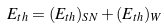Convert formula to latex. <formula><loc_0><loc_0><loc_500><loc_500>E _ { t h } = ( E _ { t h } ) _ { S N } + ( E _ { t h } ) _ { W }</formula> 